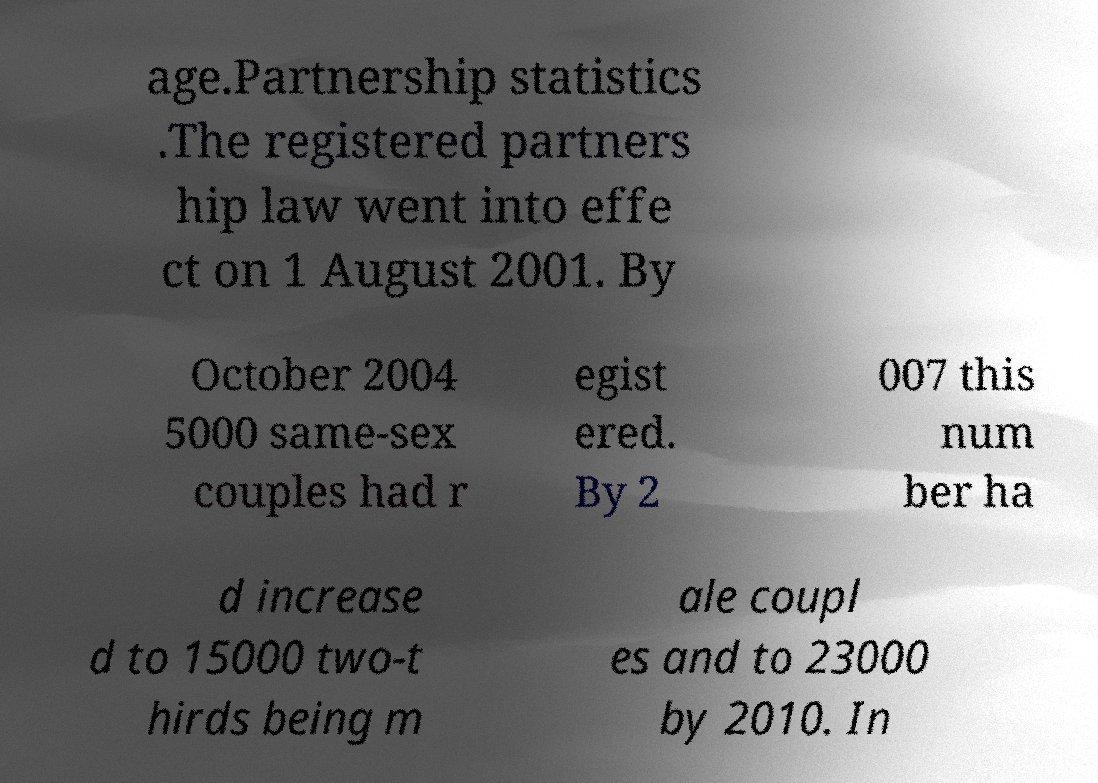Can you accurately transcribe the text from the provided image for me? age.Partnership statistics .The registered partners hip law went into effe ct on 1 August 2001. By October 2004 5000 same-sex couples had r egist ered. By 2 007 this num ber ha d increase d to 15000 two-t hirds being m ale coupl es and to 23000 by 2010. In 